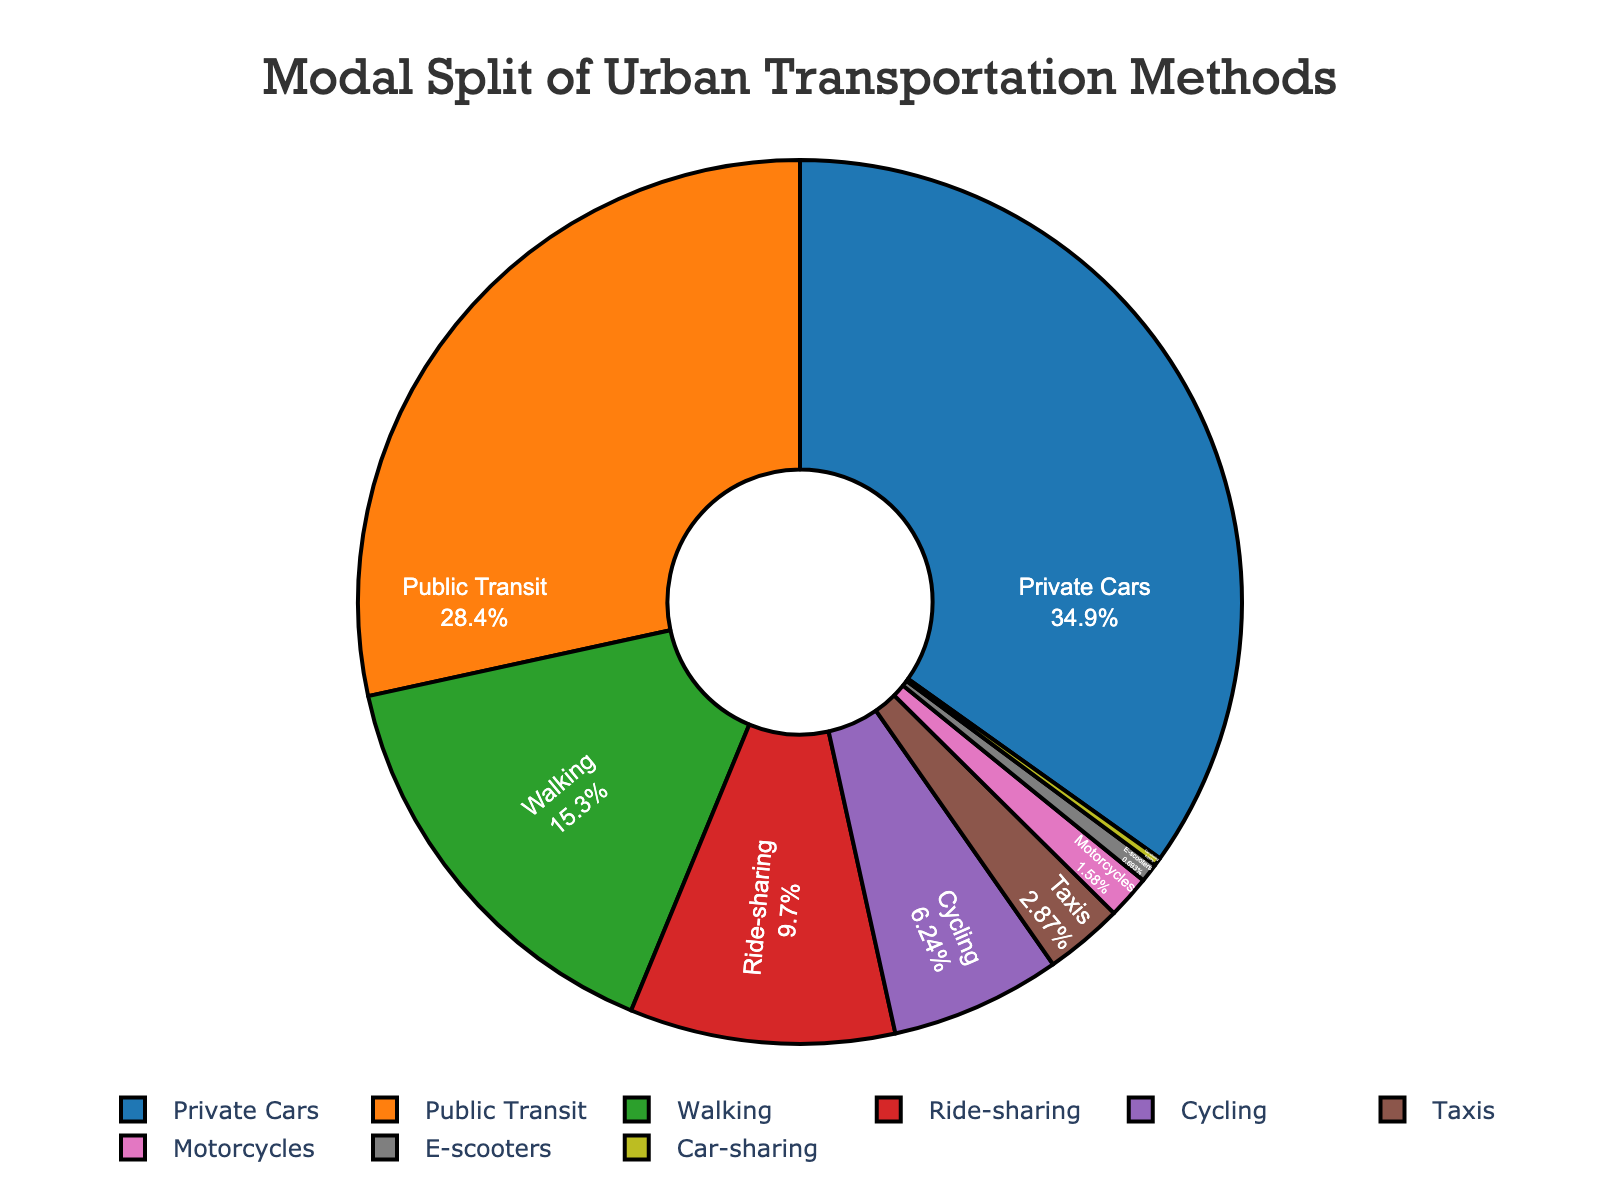What is the most common urban transportation method? By examining the pie chart, the transportation method with the largest segment represents the most common method. The largest segment is labeled "Private Cars."
Answer: Private Cars Which two transportation methods together make up more than half of the urban transportation methods? To determine this, find the percentages of the two largest segments and sum them. Private Cars (35.2%) and Public Transit (28.7%) together sum 63.9%.
Answer: Private Cars and Public Transit How much larger is the percentage of Private Cars compared to Ride-sharing? Subtract the percentage of Ride-sharing (9.8%) from the percentage of Private Cars (35.2%). 35.2% - 9.8% = 25.4%.
Answer: 25.4% What proportion of urban transportation methods is human-powered (Walking and Cycling together)? Add the percentages of Walking (15.5%) and Cycling (6.3%). 15.5% + 6.3% = 21.8%.
Answer: 21.8% Which has a smaller percentage: Taxis or Car-sharing? Compare the percentages directly from the chart. Taxis have 2.9%, and Car-sharing has 0.3%.
Answer: Car-sharing What percentage of urban transportation methods is shared among Ride-sharing, Taxis, Car-sharing, and E-scooters? Sum the percentages of Ride-sharing (9.8%), Taxis (2.9%), Car-sharing (0.3%), and E-scooters (0.7%). 9.8% + 2.9% + 0.3% + 0.7% = 13.7%.
Answer: 13.7% Is Public Transit more popular than Ride-sharing? Compare their percentages directly from the chart. Public Transit has 28.7%, while Ride-sharing has 9.8%.
Answer: Yes Which transportation method has a percentage closest to 10%? Examine the chart for percentages near 10%. Ride-sharing is closest with 9.8%.
Answer: Ride-sharing Are there more than two methods with less than 3% share? Identify the methods with less than 3% from the chart. These are Taxis (2.9%), Motorcycles (1.6%), E-scooters (0.7%), and Car-sharing (0.3%) - a total of four methods.
Answer: Yes 